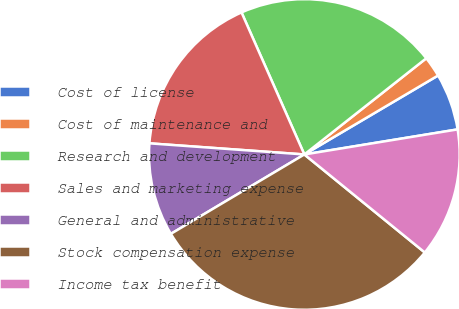Convert chart. <chart><loc_0><loc_0><loc_500><loc_500><pie_chart><fcel>Cost of license<fcel>Cost of maintenance and<fcel>Research and development<fcel>Sales and marketing expense<fcel>General and administrative<fcel>Stock compensation expense<fcel>Income tax benefit<nl><fcel>5.91%<fcel>2.14%<fcel>21.0%<fcel>17.23%<fcel>9.68%<fcel>30.59%<fcel>13.45%<nl></chart> 